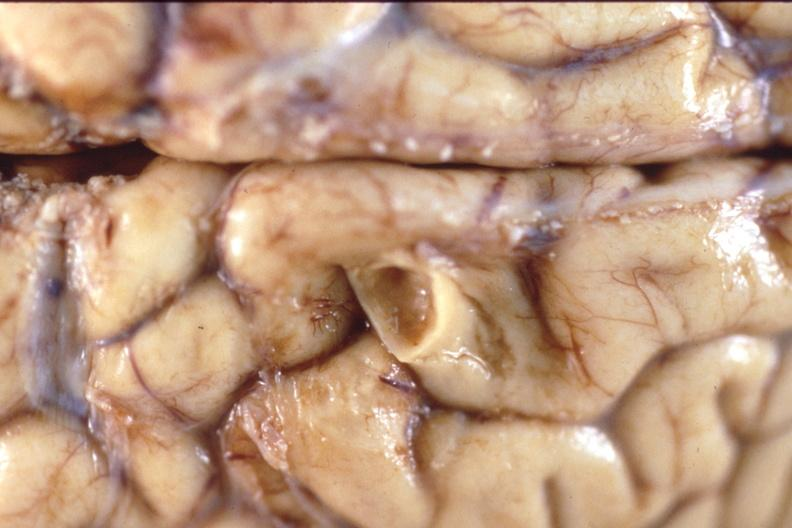what is present?
Answer the question using a single word or phrase. Nervous 